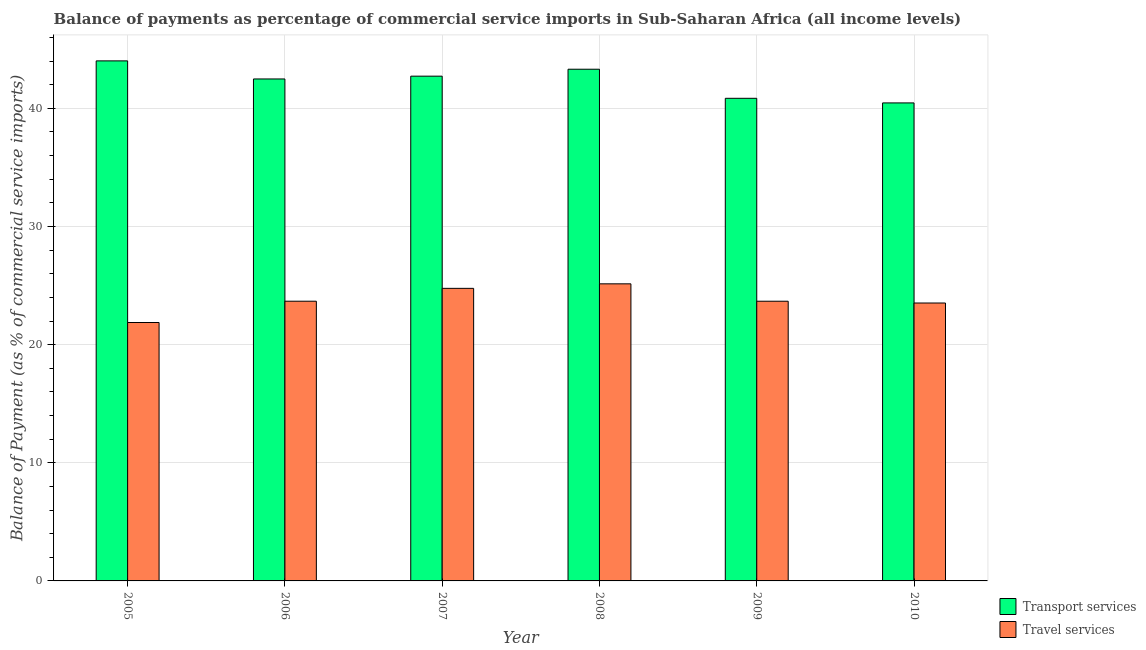How many different coloured bars are there?
Offer a terse response. 2. How many groups of bars are there?
Offer a very short reply. 6. Are the number of bars on each tick of the X-axis equal?
Your answer should be very brief. Yes. How many bars are there on the 2nd tick from the left?
Offer a terse response. 2. In how many cases, is the number of bars for a given year not equal to the number of legend labels?
Provide a succinct answer. 0. What is the balance of payments of travel services in 2007?
Ensure brevity in your answer.  24.76. Across all years, what is the maximum balance of payments of transport services?
Your response must be concise. 44.02. Across all years, what is the minimum balance of payments of transport services?
Offer a terse response. 40.46. In which year was the balance of payments of transport services minimum?
Provide a succinct answer. 2010. What is the total balance of payments of transport services in the graph?
Keep it short and to the point. 253.85. What is the difference between the balance of payments of transport services in 2006 and that in 2007?
Provide a short and direct response. -0.24. What is the difference between the balance of payments of transport services in 2010 and the balance of payments of travel services in 2009?
Your answer should be very brief. -0.39. What is the average balance of payments of travel services per year?
Your answer should be compact. 23.78. In how many years, is the balance of payments of travel services greater than 22 %?
Give a very brief answer. 5. What is the ratio of the balance of payments of transport services in 2006 to that in 2008?
Give a very brief answer. 0.98. Is the balance of payments of transport services in 2005 less than that in 2008?
Give a very brief answer. No. What is the difference between the highest and the second highest balance of payments of transport services?
Your answer should be compact. 0.71. What is the difference between the highest and the lowest balance of payments of travel services?
Your answer should be very brief. 3.27. Is the sum of the balance of payments of travel services in 2006 and 2007 greater than the maximum balance of payments of transport services across all years?
Make the answer very short. Yes. What does the 2nd bar from the left in 2008 represents?
Make the answer very short. Travel services. What does the 1st bar from the right in 2007 represents?
Make the answer very short. Travel services. How many bars are there?
Your answer should be very brief. 12. How many years are there in the graph?
Your response must be concise. 6. Are the values on the major ticks of Y-axis written in scientific E-notation?
Provide a succinct answer. No. Does the graph contain any zero values?
Ensure brevity in your answer.  No. How many legend labels are there?
Your answer should be compact. 2. What is the title of the graph?
Offer a very short reply. Balance of payments as percentage of commercial service imports in Sub-Saharan Africa (all income levels). Does "Time to import" appear as one of the legend labels in the graph?
Your answer should be compact. No. What is the label or title of the X-axis?
Give a very brief answer. Year. What is the label or title of the Y-axis?
Your answer should be very brief. Balance of Payment (as % of commercial service imports). What is the Balance of Payment (as % of commercial service imports) of Transport services in 2005?
Make the answer very short. 44.02. What is the Balance of Payment (as % of commercial service imports) of Travel services in 2005?
Provide a succinct answer. 21.87. What is the Balance of Payment (as % of commercial service imports) of Transport services in 2006?
Ensure brevity in your answer.  42.49. What is the Balance of Payment (as % of commercial service imports) of Travel services in 2006?
Provide a succinct answer. 23.67. What is the Balance of Payment (as % of commercial service imports) of Transport services in 2007?
Your response must be concise. 42.72. What is the Balance of Payment (as % of commercial service imports) in Travel services in 2007?
Make the answer very short. 24.76. What is the Balance of Payment (as % of commercial service imports) in Transport services in 2008?
Offer a very short reply. 43.31. What is the Balance of Payment (as % of commercial service imports) in Travel services in 2008?
Provide a succinct answer. 25.15. What is the Balance of Payment (as % of commercial service imports) of Transport services in 2009?
Provide a short and direct response. 40.85. What is the Balance of Payment (as % of commercial service imports) in Travel services in 2009?
Your answer should be very brief. 23.67. What is the Balance of Payment (as % of commercial service imports) of Transport services in 2010?
Offer a terse response. 40.46. What is the Balance of Payment (as % of commercial service imports) of Travel services in 2010?
Offer a very short reply. 23.52. Across all years, what is the maximum Balance of Payment (as % of commercial service imports) in Transport services?
Give a very brief answer. 44.02. Across all years, what is the maximum Balance of Payment (as % of commercial service imports) in Travel services?
Your answer should be very brief. 25.15. Across all years, what is the minimum Balance of Payment (as % of commercial service imports) of Transport services?
Make the answer very short. 40.46. Across all years, what is the minimum Balance of Payment (as % of commercial service imports) of Travel services?
Your response must be concise. 21.87. What is the total Balance of Payment (as % of commercial service imports) of Transport services in the graph?
Make the answer very short. 253.85. What is the total Balance of Payment (as % of commercial service imports) in Travel services in the graph?
Provide a succinct answer. 142.65. What is the difference between the Balance of Payment (as % of commercial service imports) in Transport services in 2005 and that in 2006?
Your answer should be very brief. 1.53. What is the difference between the Balance of Payment (as % of commercial service imports) in Travel services in 2005 and that in 2006?
Ensure brevity in your answer.  -1.8. What is the difference between the Balance of Payment (as % of commercial service imports) of Transport services in 2005 and that in 2007?
Keep it short and to the point. 1.29. What is the difference between the Balance of Payment (as % of commercial service imports) of Travel services in 2005 and that in 2007?
Your answer should be very brief. -2.89. What is the difference between the Balance of Payment (as % of commercial service imports) in Transport services in 2005 and that in 2008?
Keep it short and to the point. 0.71. What is the difference between the Balance of Payment (as % of commercial service imports) in Travel services in 2005 and that in 2008?
Offer a terse response. -3.27. What is the difference between the Balance of Payment (as % of commercial service imports) in Transport services in 2005 and that in 2009?
Provide a short and direct response. 3.17. What is the difference between the Balance of Payment (as % of commercial service imports) of Travel services in 2005 and that in 2009?
Give a very brief answer. -1.8. What is the difference between the Balance of Payment (as % of commercial service imports) in Transport services in 2005 and that in 2010?
Keep it short and to the point. 3.56. What is the difference between the Balance of Payment (as % of commercial service imports) of Travel services in 2005 and that in 2010?
Give a very brief answer. -1.65. What is the difference between the Balance of Payment (as % of commercial service imports) in Transport services in 2006 and that in 2007?
Ensure brevity in your answer.  -0.24. What is the difference between the Balance of Payment (as % of commercial service imports) in Travel services in 2006 and that in 2007?
Provide a succinct answer. -1.09. What is the difference between the Balance of Payment (as % of commercial service imports) in Transport services in 2006 and that in 2008?
Provide a succinct answer. -0.82. What is the difference between the Balance of Payment (as % of commercial service imports) in Travel services in 2006 and that in 2008?
Your answer should be compact. -1.47. What is the difference between the Balance of Payment (as % of commercial service imports) of Transport services in 2006 and that in 2009?
Offer a very short reply. 1.64. What is the difference between the Balance of Payment (as % of commercial service imports) of Travel services in 2006 and that in 2009?
Make the answer very short. 0. What is the difference between the Balance of Payment (as % of commercial service imports) of Transport services in 2006 and that in 2010?
Your answer should be very brief. 2.03. What is the difference between the Balance of Payment (as % of commercial service imports) in Travel services in 2006 and that in 2010?
Offer a very short reply. 0.15. What is the difference between the Balance of Payment (as % of commercial service imports) in Transport services in 2007 and that in 2008?
Your response must be concise. -0.59. What is the difference between the Balance of Payment (as % of commercial service imports) in Travel services in 2007 and that in 2008?
Keep it short and to the point. -0.38. What is the difference between the Balance of Payment (as % of commercial service imports) in Transport services in 2007 and that in 2009?
Ensure brevity in your answer.  1.87. What is the difference between the Balance of Payment (as % of commercial service imports) in Travel services in 2007 and that in 2009?
Offer a terse response. 1.09. What is the difference between the Balance of Payment (as % of commercial service imports) in Transport services in 2007 and that in 2010?
Your response must be concise. 2.26. What is the difference between the Balance of Payment (as % of commercial service imports) of Travel services in 2007 and that in 2010?
Your answer should be compact. 1.24. What is the difference between the Balance of Payment (as % of commercial service imports) in Transport services in 2008 and that in 2009?
Your answer should be very brief. 2.46. What is the difference between the Balance of Payment (as % of commercial service imports) in Travel services in 2008 and that in 2009?
Give a very brief answer. 1.47. What is the difference between the Balance of Payment (as % of commercial service imports) of Transport services in 2008 and that in 2010?
Give a very brief answer. 2.85. What is the difference between the Balance of Payment (as % of commercial service imports) in Travel services in 2008 and that in 2010?
Ensure brevity in your answer.  1.62. What is the difference between the Balance of Payment (as % of commercial service imports) in Transport services in 2009 and that in 2010?
Keep it short and to the point. 0.39. What is the difference between the Balance of Payment (as % of commercial service imports) in Travel services in 2009 and that in 2010?
Keep it short and to the point. 0.15. What is the difference between the Balance of Payment (as % of commercial service imports) of Transport services in 2005 and the Balance of Payment (as % of commercial service imports) of Travel services in 2006?
Provide a short and direct response. 20.34. What is the difference between the Balance of Payment (as % of commercial service imports) in Transport services in 2005 and the Balance of Payment (as % of commercial service imports) in Travel services in 2007?
Your response must be concise. 19.25. What is the difference between the Balance of Payment (as % of commercial service imports) of Transport services in 2005 and the Balance of Payment (as % of commercial service imports) of Travel services in 2008?
Provide a succinct answer. 18.87. What is the difference between the Balance of Payment (as % of commercial service imports) of Transport services in 2005 and the Balance of Payment (as % of commercial service imports) of Travel services in 2009?
Make the answer very short. 20.34. What is the difference between the Balance of Payment (as % of commercial service imports) of Transport services in 2005 and the Balance of Payment (as % of commercial service imports) of Travel services in 2010?
Your response must be concise. 20.49. What is the difference between the Balance of Payment (as % of commercial service imports) of Transport services in 2006 and the Balance of Payment (as % of commercial service imports) of Travel services in 2007?
Give a very brief answer. 17.72. What is the difference between the Balance of Payment (as % of commercial service imports) in Transport services in 2006 and the Balance of Payment (as % of commercial service imports) in Travel services in 2008?
Your answer should be compact. 17.34. What is the difference between the Balance of Payment (as % of commercial service imports) of Transport services in 2006 and the Balance of Payment (as % of commercial service imports) of Travel services in 2009?
Your response must be concise. 18.81. What is the difference between the Balance of Payment (as % of commercial service imports) in Transport services in 2006 and the Balance of Payment (as % of commercial service imports) in Travel services in 2010?
Your answer should be compact. 18.96. What is the difference between the Balance of Payment (as % of commercial service imports) of Transport services in 2007 and the Balance of Payment (as % of commercial service imports) of Travel services in 2008?
Ensure brevity in your answer.  17.58. What is the difference between the Balance of Payment (as % of commercial service imports) of Transport services in 2007 and the Balance of Payment (as % of commercial service imports) of Travel services in 2009?
Make the answer very short. 19.05. What is the difference between the Balance of Payment (as % of commercial service imports) of Transport services in 2007 and the Balance of Payment (as % of commercial service imports) of Travel services in 2010?
Offer a very short reply. 19.2. What is the difference between the Balance of Payment (as % of commercial service imports) in Transport services in 2008 and the Balance of Payment (as % of commercial service imports) in Travel services in 2009?
Offer a very short reply. 19.64. What is the difference between the Balance of Payment (as % of commercial service imports) of Transport services in 2008 and the Balance of Payment (as % of commercial service imports) of Travel services in 2010?
Ensure brevity in your answer.  19.79. What is the difference between the Balance of Payment (as % of commercial service imports) of Transport services in 2009 and the Balance of Payment (as % of commercial service imports) of Travel services in 2010?
Make the answer very short. 17.33. What is the average Balance of Payment (as % of commercial service imports) in Transport services per year?
Provide a succinct answer. 42.31. What is the average Balance of Payment (as % of commercial service imports) in Travel services per year?
Offer a terse response. 23.78. In the year 2005, what is the difference between the Balance of Payment (as % of commercial service imports) in Transport services and Balance of Payment (as % of commercial service imports) in Travel services?
Your response must be concise. 22.15. In the year 2006, what is the difference between the Balance of Payment (as % of commercial service imports) of Transport services and Balance of Payment (as % of commercial service imports) of Travel services?
Your answer should be very brief. 18.81. In the year 2007, what is the difference between the Balance of Payment (as % of commercial service imports) in Transport services and Balance of Payment (as % of commercial service imports) in Travel services?
Keep it short and to the point. 17.96. In the year 2008, what is the difference between the Balance of Payment (as % of commercial service imports) in Transport services and Balance of Payment (as % of commercial service imports) in Travel services?
Offer a terse response. 18.16. In the year 2009, what is the difference between the Balance of Payment (as % of commercial service imports) of Transport services and Balance of Payment (as % of commercial service imports) of Travel services?
Keep it short and to the point. 17.18. In the year 2010, what is the difference between the Balance of Payment (as % of commercial service imports) in Transport services and Balance of Payment (as % of commercial service imports) in Travel services?
Your answer should be compact. 16.94. What is the ratio of the Balance of Payment (as % of commercial service imports) in Transport services in 2005 to that in 2006?
Keep it short and to the point. 1.04. What is the ratio of the Balance of Payment (as % of commercial service imports) in Travel services in 2005 to that in 2006?
Your answer should be compact. 0.92. What is the ratio of the Balance of Payment (as % of commercial service imports) in Transport services in 2005 to that in 2007?
Your answer should be very brief. 1.03. What is the ratio of the Balance of Payment (as % of commercial service imports) of Travel services in 2005 to that in 2007?
Ensure brevity in your answer.  0.88. What is the ratio of the Balance of Payment (as % of commercial service imports) of Transport services in 2005 to that in 2008?
Offer a terse response. 1.02. What is the ratio of the Balance of Payment (as % of commercial service imports) in Travel services in 2005 to that in 2008?
Ensure brevity in your answer.  0.87. What is the ratio of the Balance of Payment (as % of commercial service imports) in Transport services in 2005 to that in 2009?
Your answer should be very brief. 1.08. What is the ratio of the Balance of Payment (as % of commercial service imports) of Travel services in 2005 to that in 2009?
Give a very brief answer. 0.92. What is the ratio of the Balance of Payment (as % of commercial service imports) in Transport services in 2005 to that in 2010?
Give a very brief answer. 1.09. What is the ratio of the Balance of Payment (as % of commercial service imports) of Travel services in 2005 to that in 2010?
Ensure brevity in your answer.  0.93. What is the ratio of the Balance of Payment (as % of commercial service imports) in Travel services in 2006 to that in 2007?
Offer a terse response. 0.96. What is the ratio of the Balance of Payment (as % of commercial service imports) in Travel services in 2006 to that in 2008?
Give a very brief answer. 0.94. What is the ratio of the Balance of Payment (as % of commercial service imports) in Transport services in 2006 to that in 2009?
Provide a succinct answer. 1.04. What is the ratio of the Balance of Payment (as % of commercial service imports) of Transport services in 2006 to that in 2010?
Offer a terse response. 1.05. What is the ratio of the Balance of Payment (as % of commercial service imports) in Travel services in 2006 to that in 2010?
Provide a short and direct response. 1.01. What is the ratio of the Balance of Payment (as % of commercial service imports) of Transport services in 2007 to that in 2008?
Offer a very short reply. 0.99. What is the ratio of the Balance of Payment (as % of commercial service imports) of Travel services in 2007 to that in 2008?
Ensure brevity in your answer.  0.98. What is the ratio of the Balance of Payment (as % of commercial service imports) of Transport services in 2007 to that in 2009?
Ensure brevity in your answer.  1.05. What is the ratio of the Balance of Payment (as % of commercial service imports) in Travel services in 2007 to that in 2009?
Give a very brief answer. 1.05. What is the ratio of the Balance of Payment (as % of commercial service imports) in Transport services in 2007 to that in 2010?
Give a very brief answer. 1.06. What is the ratio of the Balance of Payment (as % of commercial service imports) of Travel services in 2007 to that in 2010?
Give a very brief answer. 1.05. What is the ratio of the Balance of Payment (as % of commercial service imports) of Transport services in 2008 to that in 2009?
Make the answer very short. 1.06. What is the ratio of the Balance of Payment (as % of commercial service imports) of Travel services in 2008 to that in 2009?
Provide a succinct answer. 1.06. What is the ratio of the Balance of Payment (as % of commercial service imports) in Transport services in 2008 to that in 2010?
Your answer should be very brief. 1.07. What is the ratio of the Balance of Payment (as % of commercial service imports) in Travel services in 2008 to that in 2010?
Provide a succinct answer. 1.07. What is the ratio of the Balance of Payment (as % of commercial service imports) in Transport services in 2009 to that in 2010?
Give a very brief answer. 1.01. What is the ratio of the Balance of Payment (as % of commercial service imports) in Travel services in 2009 to that in 2010?
Ensure brevity in your answer.  1.01. What is the difference between the highest and the second highest Balance of Payment (as % of commercial service imports) of Transport services?
Offer a very short reply. 0.71. What is the difference between the highest and the second highest Balance of Payment (as % of commercial service imports) in Travel services?
Provide a succinct answer. 0.38. What is the difference between the highest and the lowest Balance of Payment (as % of commercial service imports) of Transport services?
Offer a terse response. 3.56. What is the difference between the highest and the lowest Balance of Payment (as % of commercial service imports) of Travel services?
Offer a terse response. 3.27. 